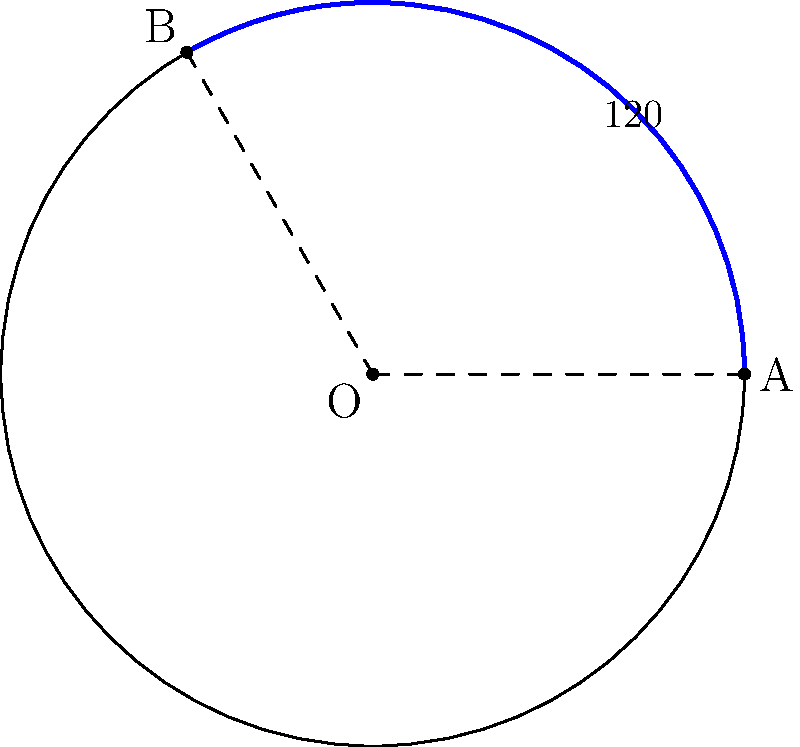In the ancient circular plaza of Stonehaven, archaeologists have uncovered a sector-shaped area of historical significance. The plaza has a radius of 30 meters, and the sector spans an angle of 120°. Calculate the area of this historically important sector to determine the extent of the conservation efforts required. To calculate the area of the sector, we'll follow these steps:

1) The formula for the area of a sector is:
   $$A = \frac{\theta}{360°} \pi r^2$$
   where $\theta$ is the central angle in degrees, and $r$ is the radius.

2) We're given:
   - Radius ($r$) = 30 meters
   - Central angle ($\theta$) = 120°

3) Let's substitute these values into our formula:
   $$A = \frac{120°}{360°} \pi (30\text{ m})^2$$

4) Simplify the fraction:
   $$A = \frac{1}{3} \pi (30\text{ m})^2$$

5) Calculate the square of the radius:
   $$A = \frac{1}{3} \pi (900\text{ m}^2)$$

6) Multiply:
   $$A = 300\pi\text{ m}^2$$

7) If we need a decimal approximation:
   $$A \approx 942.48\text{ m}^2$$

Thus, the area of the historically significant sector is $300\pi$ square meters or approximately 942.48 square meters.
Answer: $300\pi\text{ m}^2$ 